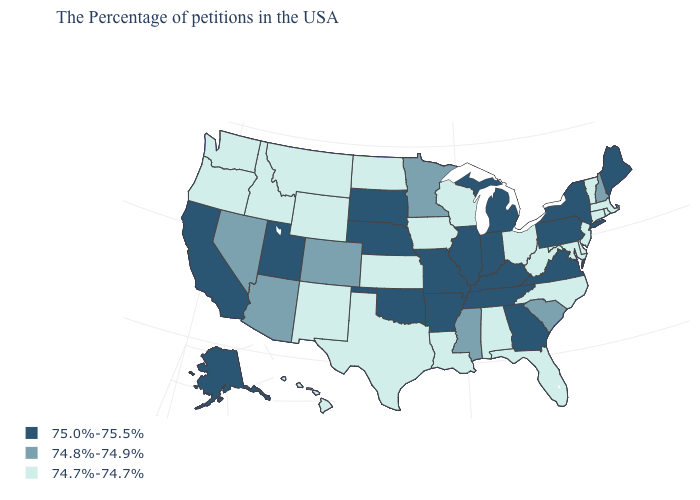Does Maine have the highest value in the Northeast?
Short answer required. Yes. What is the highest value in the USA?
Keep it brief. 75.0%-75.5%. Does Tennessee have the same value as Virginia?
Be succinct. Yes. Does the map have missing data?
Answer briefly. No. Which states have the highest value in the USA?
Concise answer only. Maine, New York, Pennsylvania, Virginia, Georgia, Michigan, Kentucky, Indiana, Tennessee, Illinois, Missouri, Arkansas, Nebraska, Oklahoma, South Dakota, Utah, California, Alaska. Is the legend a continuous bar?
Concise answer only. No. Does Maine have the lowest value in the Northeast?
Give a very brief answer. No. Name the states that have a value in the range 74.8%-74.9%?
Keep it brief. New Hampshire, South Carolina, Mississippi, Minnesota, Colorado, Arizona, Nevada. What is the highest value in states that border Washington?
Give a very brief answer. 74.7%-74.7%. Which states have the lowest value in the MidWest?
Concise answer only. Ohio, Wisconsin, Iowa, Kansas, North Dakota. What is the value of Missouri?
Quick response, please. 75.0%-75.5%. What is the value of Minnesota?
Keep it brief. 74.8%-74.9%. What is the lowest value in the South?
Keep it brief. 74.7%-74.7%. Name the states that have a value in the range 74.8%-74.9%?
Short answer required. New Hampshire, South Carolina, Mississippi, Minnesota, Colorado, Arizona, Nevada. What is the lowest value in the USA?
Answer briefly. 74.7%-74.7%. 